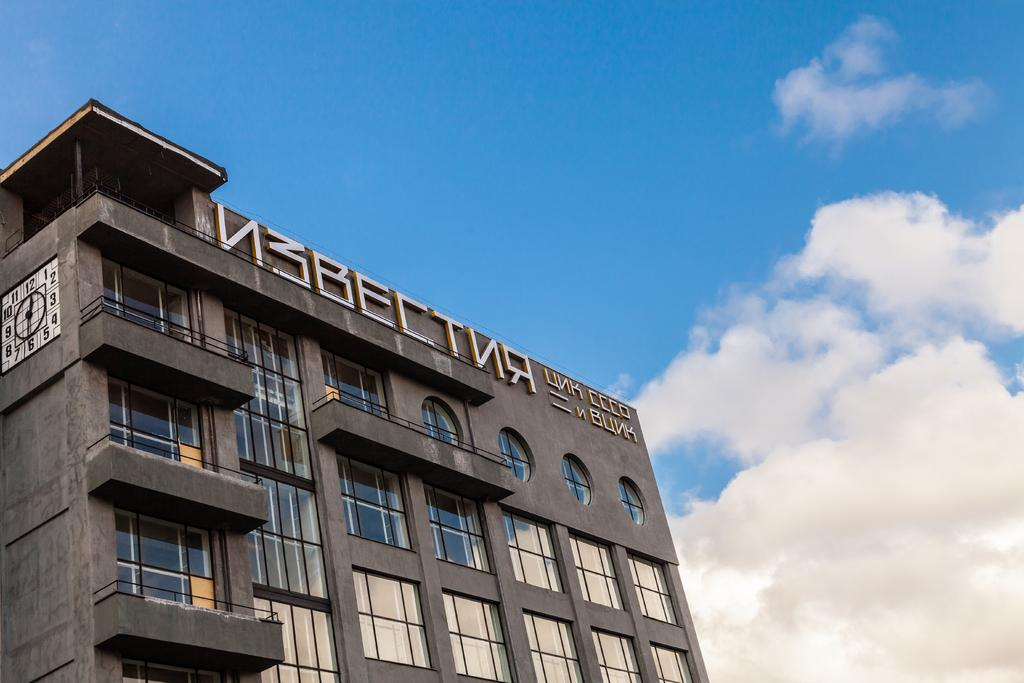What is the main subject of the picture? The main subject of the picture is a building. What specific features can be seen on the building? The building has windows and a clock. What can be seen in the background of the picture? The sky is visible in the background of the picture. How many angles can be seen holding an umbrella in the image? There are no angles or umbrellas present in the image. What type of tramp is sitting on the roof of the building in the image? There is no tramp or any person on the roof of the building in the image. 